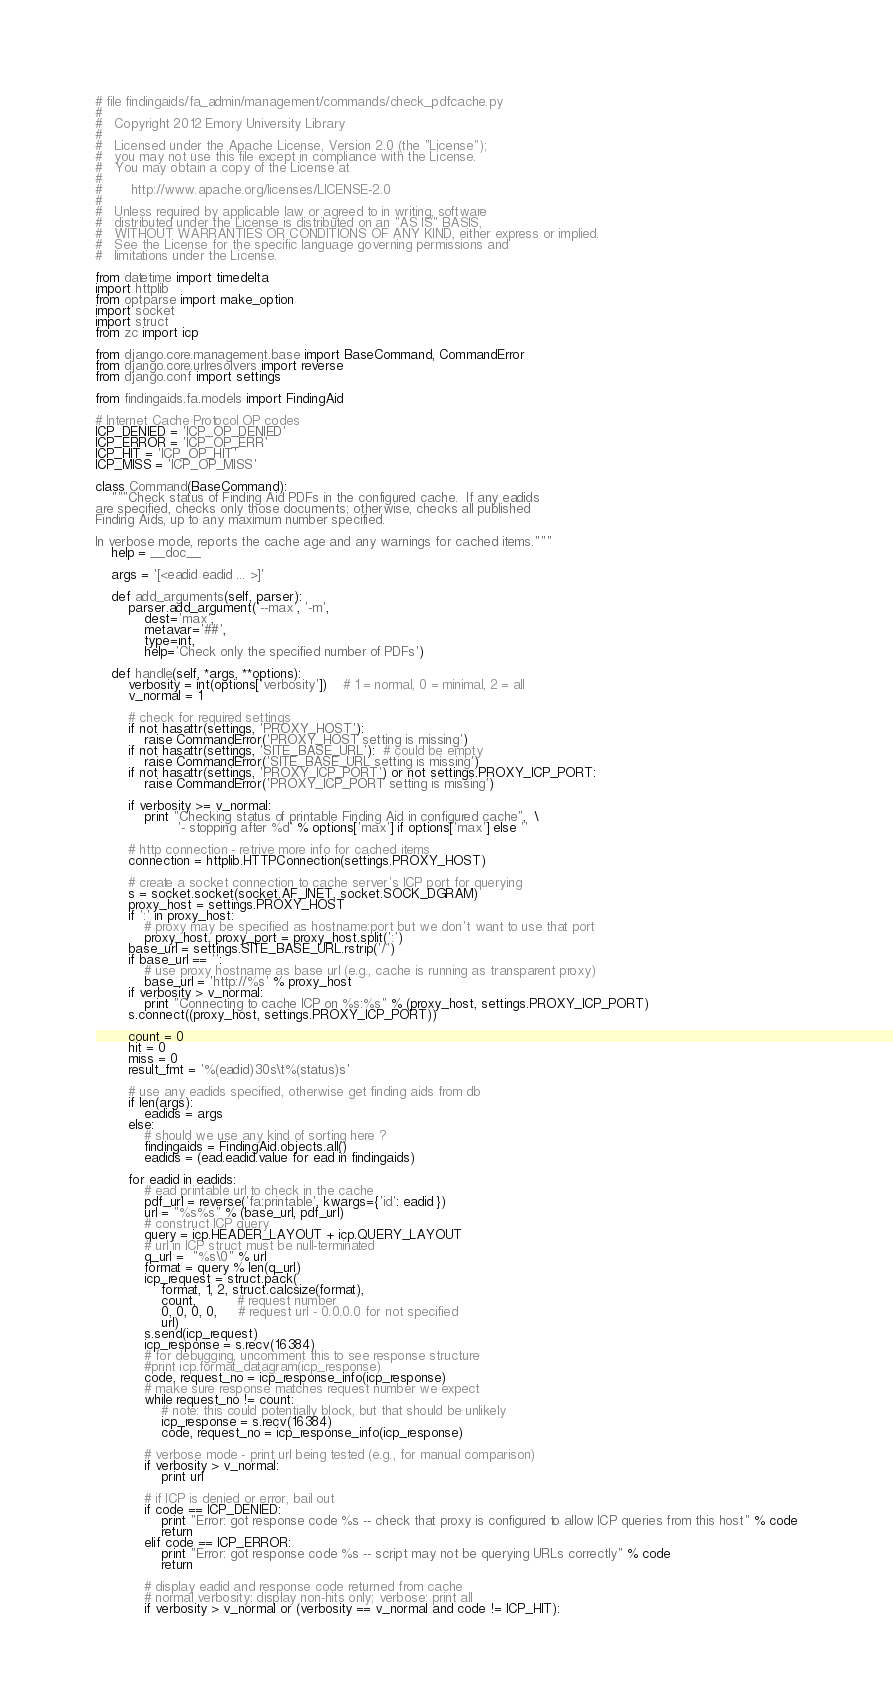<code> <loc_0><loc_0><loc_500><loc_500><_Python_># file findingaids/fa_admin/management/commands/check_pdfcache.py
#
#   Copyright 2012 Emory University Library
#
#   Licensed under the Apache License, Version 2.0 (the "License");
#   you may not use this file except in compliance with the License.
#   You may obtain a copy of the License at
#
#       http://www.apache.org/licenses/LICENSE-2.0
#
#   Unless required by applicable law or agreed to in writing, software
#   distributed under the License is distributed on an "AS IS" BASIS,
#   WITHOUT WARRANTIES OR CONDITIONS OF ANY KIND, either express or implied.
#   See the License for the specific language governing permissions and
#   limitations under the License.

from datetime import timedelta
import httplib
from optparse import make_option
import socket
import struct
from zc import icp

from django.core.management.base import BaseCommand, CommandError
from django.core.urlresolvers import reverse
from django.conf import settings

from findingaids.fa.models import FindingAid

# Internet Cache Protocol OP codes
ICP_DENIED = 'ICP_OP_DENIED'
ICP_ERROR = 'ICP_OP_ERR'
ICP_HIT = 'ICP_OP_HIT'
ICP_MISS = 'ICP_OP_MISS'

class Command(BaseCommand):
    """Check status of Finding Aid PDFs in the configured cache.  If any eadids
are specified, checks only those documents; otherwise, checks all published
Finding Aids, up to any maximum number specified.

In verbose mode, reports the cache age and any warnings for cached items."""
    help = __doc__

    args = '[<eadid eadid ... >]'

    def add_arguments(self, parser):
        parser.add_argument('--max', '-m',
            dest='max',
            metavar='##',
            type=int,
            help='Check only the specified number of PDFs')

    def handle(self, *args, **options):
        verbosity = int(options['verbosity'])    # 1 = normal, 0 = minimal, 2 = all
        v_normal = 1

        # check for required settings
        if not hasattr(settings, 'PROXY_HOST'):
            raise CommandError('PROXY_HOST setting is missing')
        if not hasattr(settings, 'SITE_BASE_URL'):  # could be empty
            raise CommandError('SITE_BASE_URL setting is missing')
        if not hasattr(settings, 'PROXY_ICP_PORT') or not settings.PROXY_ICP_PORT:
            raise CommandError('PROXY_ICP_PORT setting is missing')

        if verbosity >= v_normal:
            print "Checking status of printable Finding Aid in configured cache",  \
                    '- stopping after %d' % options['max'] if options['max'] else ''

        # http connection - retrive more info for cached items
        connection = httplib.HTTPConnection(settings.PROXY_HOST)

        # create a socket connection to cache server's ICP port for querying
        s = socket.socket(socket.AF_INET, socket.SOCK_DGRAM)
        proxy_host = settings.PROXY_HOST
        if ':' in proxy_host:
            # proxy may be specified as hostname:port but we don't want to use that port
            proxy_host, proxy_port = proxy_host.split(':')
        base_url = settings.SITE_BASE_URL.rstrip('/')
        if base_url == '':
            # use proxy hostname as base url (e.g., cache is running as transparent proxy)
            base_url = 'http://%s' % proxy_host
        if verbosity > v_normal:
            print "Connecting to cache ICP on %s:%s" % (proxy_host, settings.PROXY_ICP_PORT)
        s.connect((proxy_host, settings.PROXY_ICP_PORT))

        count = 0
        hit = 0
        miss = 0
        result_fmt = '%(eadid)30s\t%(status)s'

        # use any eadids specified, otherwise get finding aids from db
        if len(args):
            eadids = args
        else:
            # should we use any kind of sorting here ?
            findingaids = FindingAid.objects.all()
            eadids = (ead.eadid.value for ead in findingaids)

        for eadid in eadids:
            # ead printable url to check in the cache
            pdf_url = reverse('fa:printable', kwargs={'id': eadid })
            url = "%s%s" % (base_url, pdf_url)
            # construct ICP query
            query = icp.HEADER_LAYOUT + icp.QUERY_LAYOUT
            # url in ICP struct must be null-terminated
            q_url =  "%s\0" % url
            format = query % len(q_url)
            icp_request = struct.pack(
                format, 1, 2, struct.calcsize(format),
                count,          # request number
                0, 0, 0, 0,     # request url - 0.0.0.0 for not specified
                url)
            s.send(icp_request)
            icp_response = s.recv(16384)
            # for debugging, uncomment this to see response structure
            #print icp.format_datagram(icp_response)
            code, request_no = icp_response_info(icp_response)
            # make sure response matches request number we expect
            while request_no != count:
                # note: this could potentially block, but that should be unlikely
                icp_response = s.recv(16384)
                code, request_no = icp_response_info(icp_response)

            # verbose mode - print url being tested (e.g., for manual comparison)
            if verbosity > v_normal:
                print url

            # if ICP is denied or error, bail out
            if code == ICP_DENIED:
                print "Error: got response code %s -- check that proxy is configured to allow ICP queries from this host" % code
                return
            elif code == ICP_ERROR:
                print "Error: got response code %s -- script may not be querying URLs correctly" % code
                return

            # display eadid and response code returned from cache
            # normal verbosity: display non-hits only; verbose: print all
            if verbosity > v_normal or (verbosity == v_normal and code != ICP_HIT):</code> 